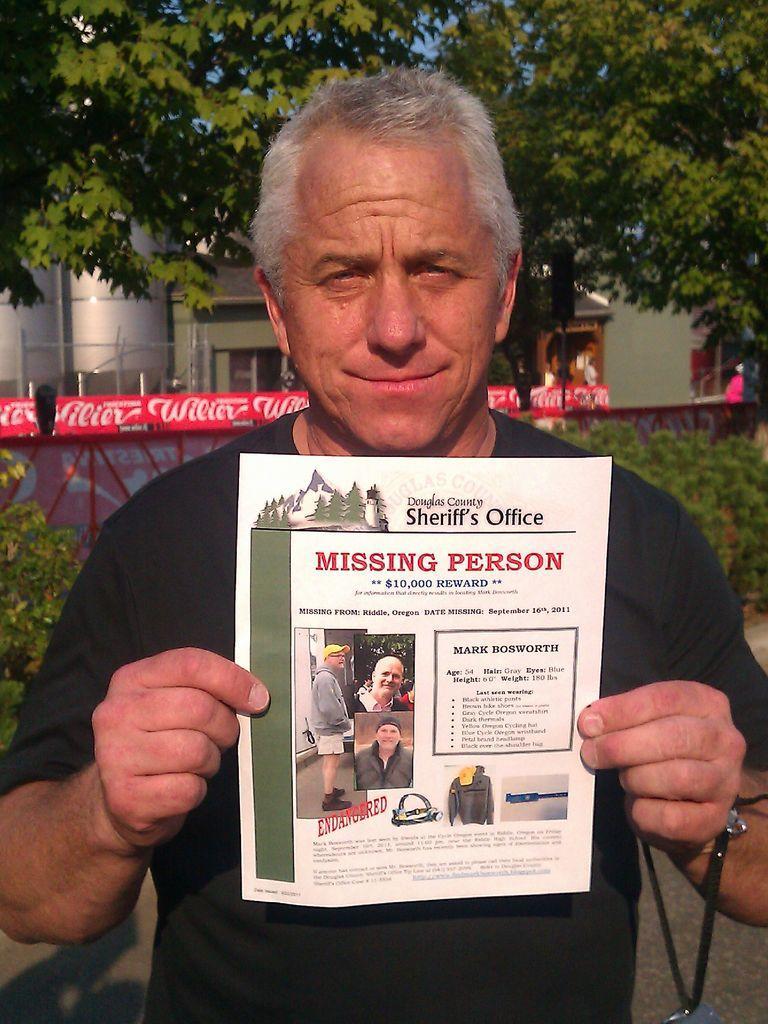Please provide a concise description of this image. In this picture, there is a man holding a pamphlet. On the pamphlet, there is some text and pictures of a man. In the background, there are trees, houses, plants etc. 